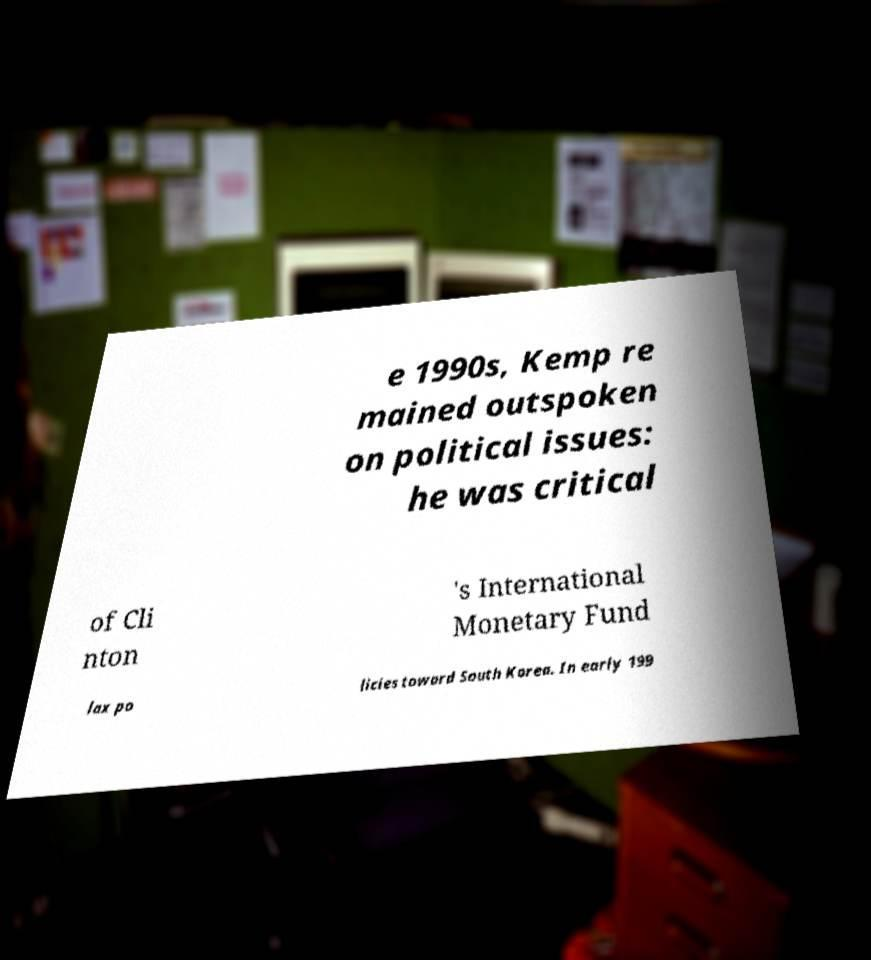What messages or text are displayed in this image? I need them in a readable, typed format. e 1990s, Kemp re mained outspoken on political issues: he was critical of Cli nton 's International Monetary Fund lax po licies toward South Korea. In early 199 